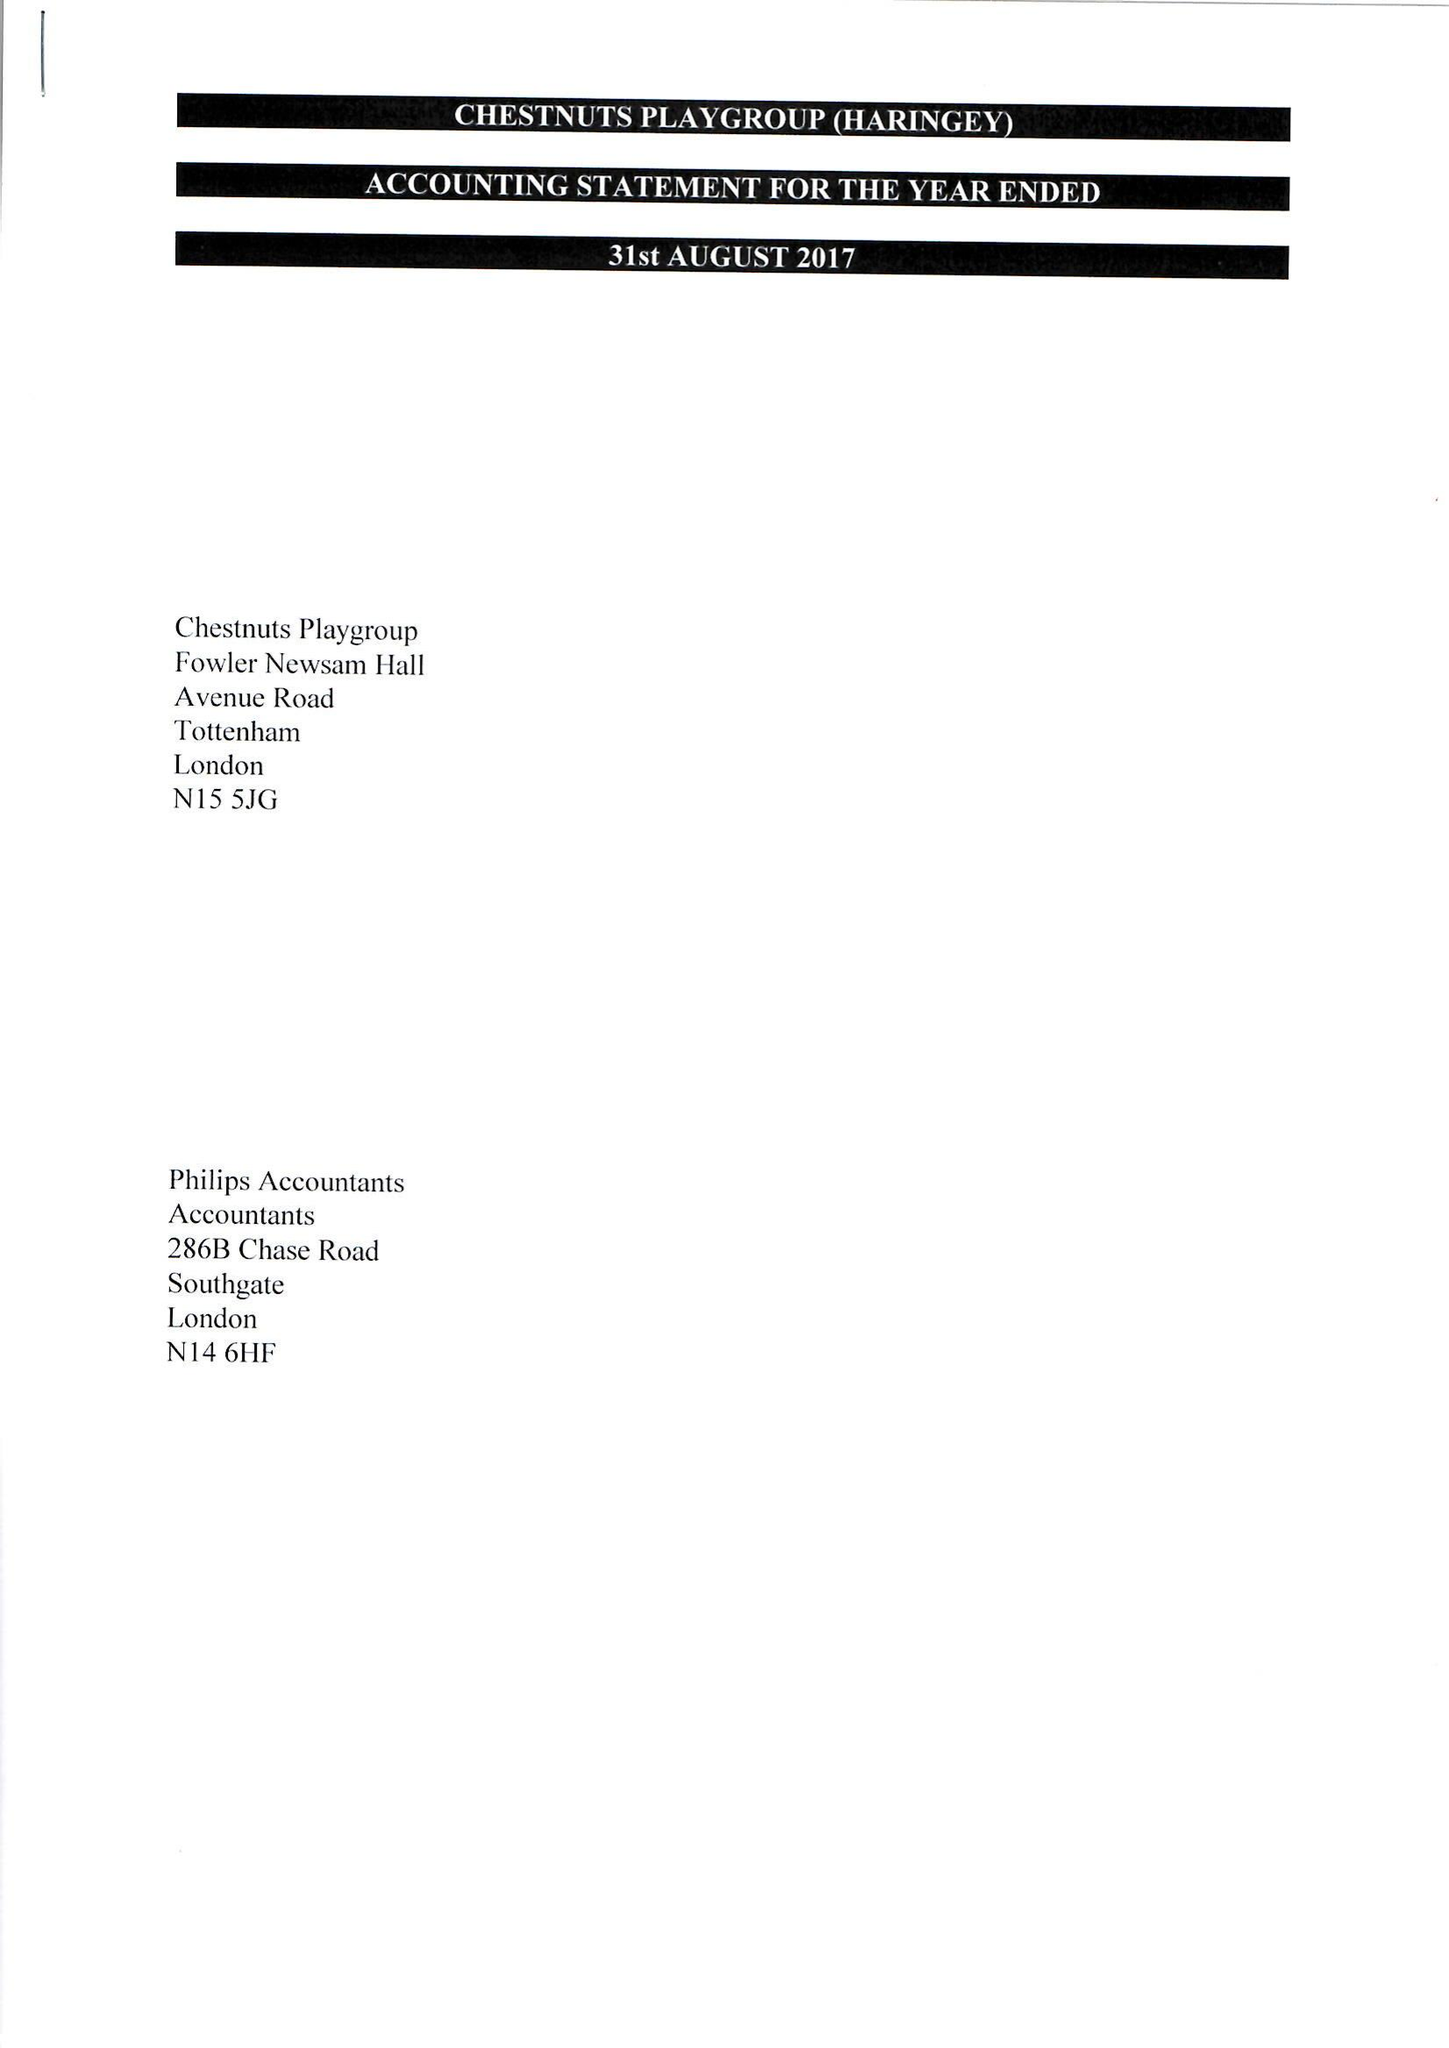What is the value for the spending_annually_in_british_pounds?
Answer the question using a single word or phrase. 91264.00 